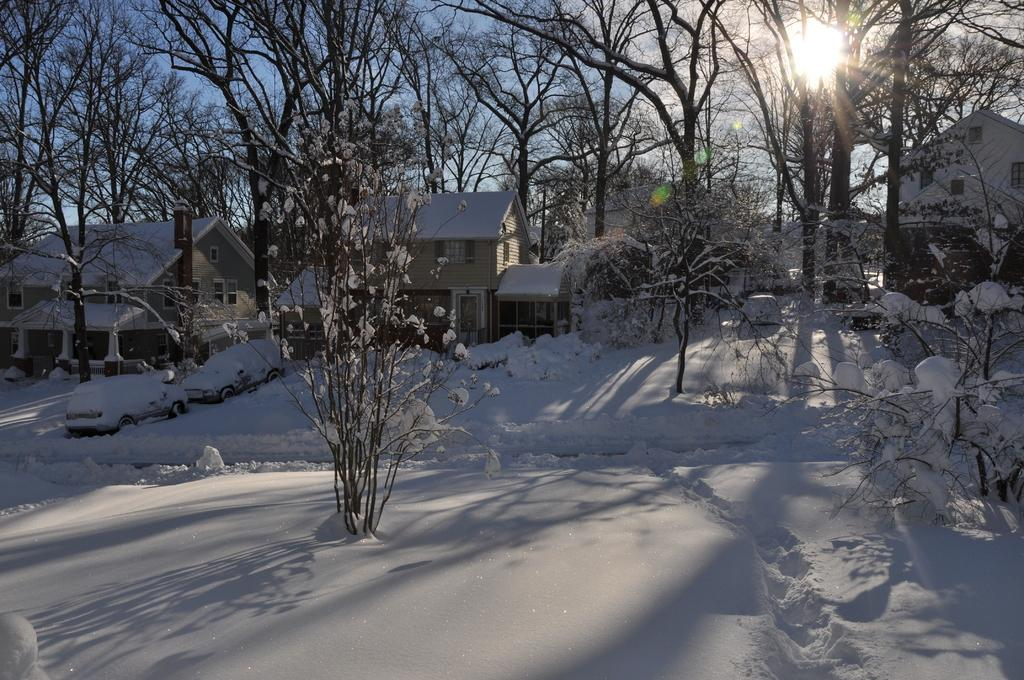What type of natural elements can be seen in the image? There are seeds and trees visible in the image. What is the ground covered with in the image? There is snow at the bottom of the image. What can be seen in the background of the image? The sky is visible in the background of the image. Can the sun be seen in the image? Yes, the sun is observable in the sky. What type of kite is being flown by the person wearing a crown in the image? There is no person wearing a crown or flying a kite present in the image. 